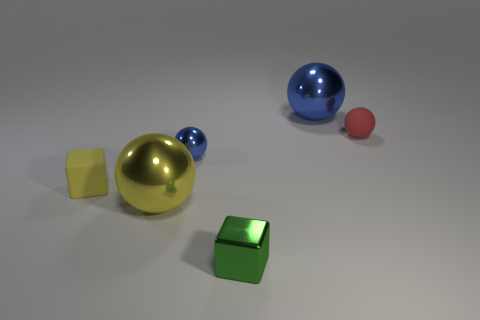Subtract all brown balls. Subtract all green blocks. How many balls are left? 4 Add 3 tiny red objects. How many objects exist? 9 Subtract all spheres. How many objects are left? 2 Subtract all tiny yellow matte blocks. Subtract all large blue things. How many objects are left? 4 Add 3 large blue objects. How many large blue objects are left? 4 Add 6 small spheres. How many small spheres exist? 8 Subtract 0 blue cylinders. How many objects are left? 6 